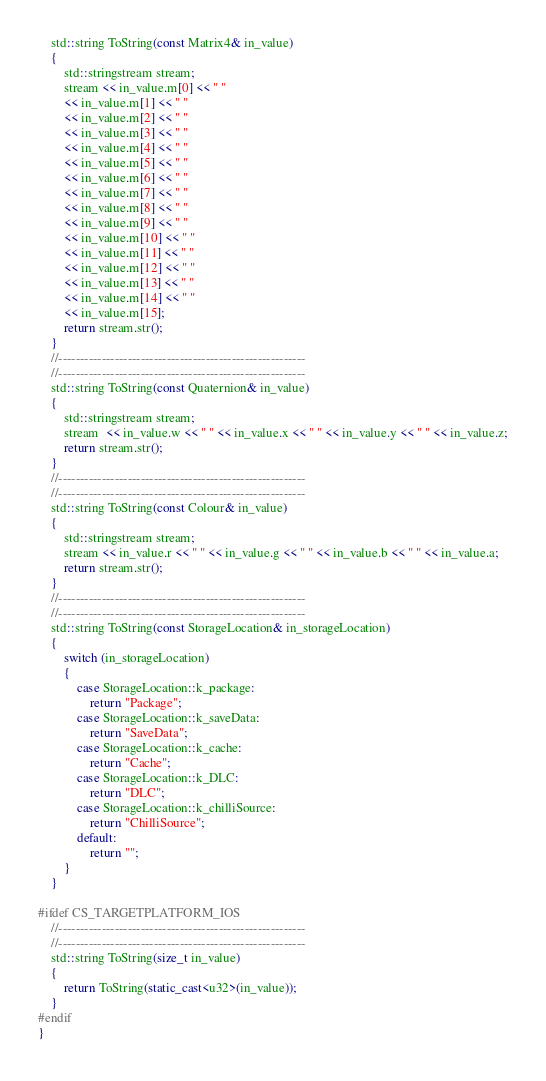<code> <loc_0><loc_0><loc_500><loc_500><_C++_>    std::string ToString(const Matrix4& in_value)
    {
        std::stringstream stream;
        stream << in_value.m[0] << " "
        << in_value.m[1] << " "
        << in_value.m[2] << " "
        << in_value.m[3] << " "
        << in_value.m[4] << " "
        << in_value.m[5] << " "
        << in_value.m[6] << " "
        << in_value.m[7] << " "
        << in_value.m[8] << " "
        << in_value.m[9] << " "
        << in_value.m[10] << " "
        << in_value.m[11] << " "
        << in_value.m[12] << " "
        << in_value.m[13] << " "
        << in_value.m[14] << " "
        << in_value.m[15];
        return stream.str();
    }
    //---------------------------------------------------------
    //---------------------------------------------------------
    std::string ToString(const Quaternion& in_value)
    {
        std::stringstream stream;
        stream  << in_value.w << " " << in_value.x << " " << in_value.y << " " << in_value.z;
        return stream.str();
    }
    //---------------------------------------------------------
    //---------------------------------------------------------
    std::string ToString(const Colour& in_value)
    {
        std::stringstream stream;
        stream << in_value.r << " " << in_value.g << " " << in_value.b << " " << in_value.a;
        return stream.str();
    }
    //---------------------------------------------------------
    //---------------------------------------------------------
    std::string ToString(const StorageLocation& in_storageLocation)
    {
        switch (in_storageLocation)
        {
            case StorageLocation::k_package:
                return "Package";
            case StorageLocation::k_saveData:
                return "SaveData";
            case StorageLocation::k_cache:
                return "Cache";
            case StorageLocation::k_DLC:
                return "DLC";
            case StorageLocation::k_chilliSource:
                return "ChilliSource";
            default:
                return "";
        }
    }
    
#ifdef CS_TARGETPLATFORM_IOS
    //---------------------------------------------------------
    //---------------------------------------------------------
    std::string ToString(size_t in_value)
    {
        return ToString(static_cast<u32>(in_value));
    }
#endif
}
</code> 